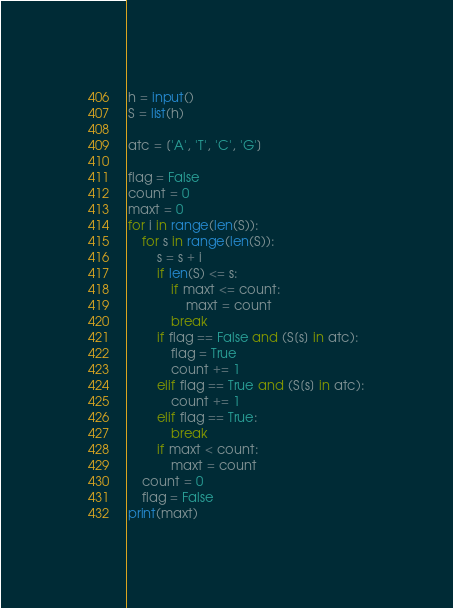Convert code to text. <code><loc_0><loc_0><loc_500><loc_500><_Python_>h = input()
S = list(h)

atc = ['A', 'T', 'C', 'G']

flag = False
count = 0
maxt = 0
for i in range(len(S)):
    for s in range(len(S)):
        s = s + i
        if len(S) <= s:
            if maxt <= count:
                maxt = count
            break
        if flag == False and (S[s] in atc):
            flag = True
            count += 1
        elif flag == True and (S[s] in atc):
            count += 1
        elif flag == True:
            break
        if maxt < count:
            maxt = count
    count = 0
    flag = False
print(maxt)</code> 